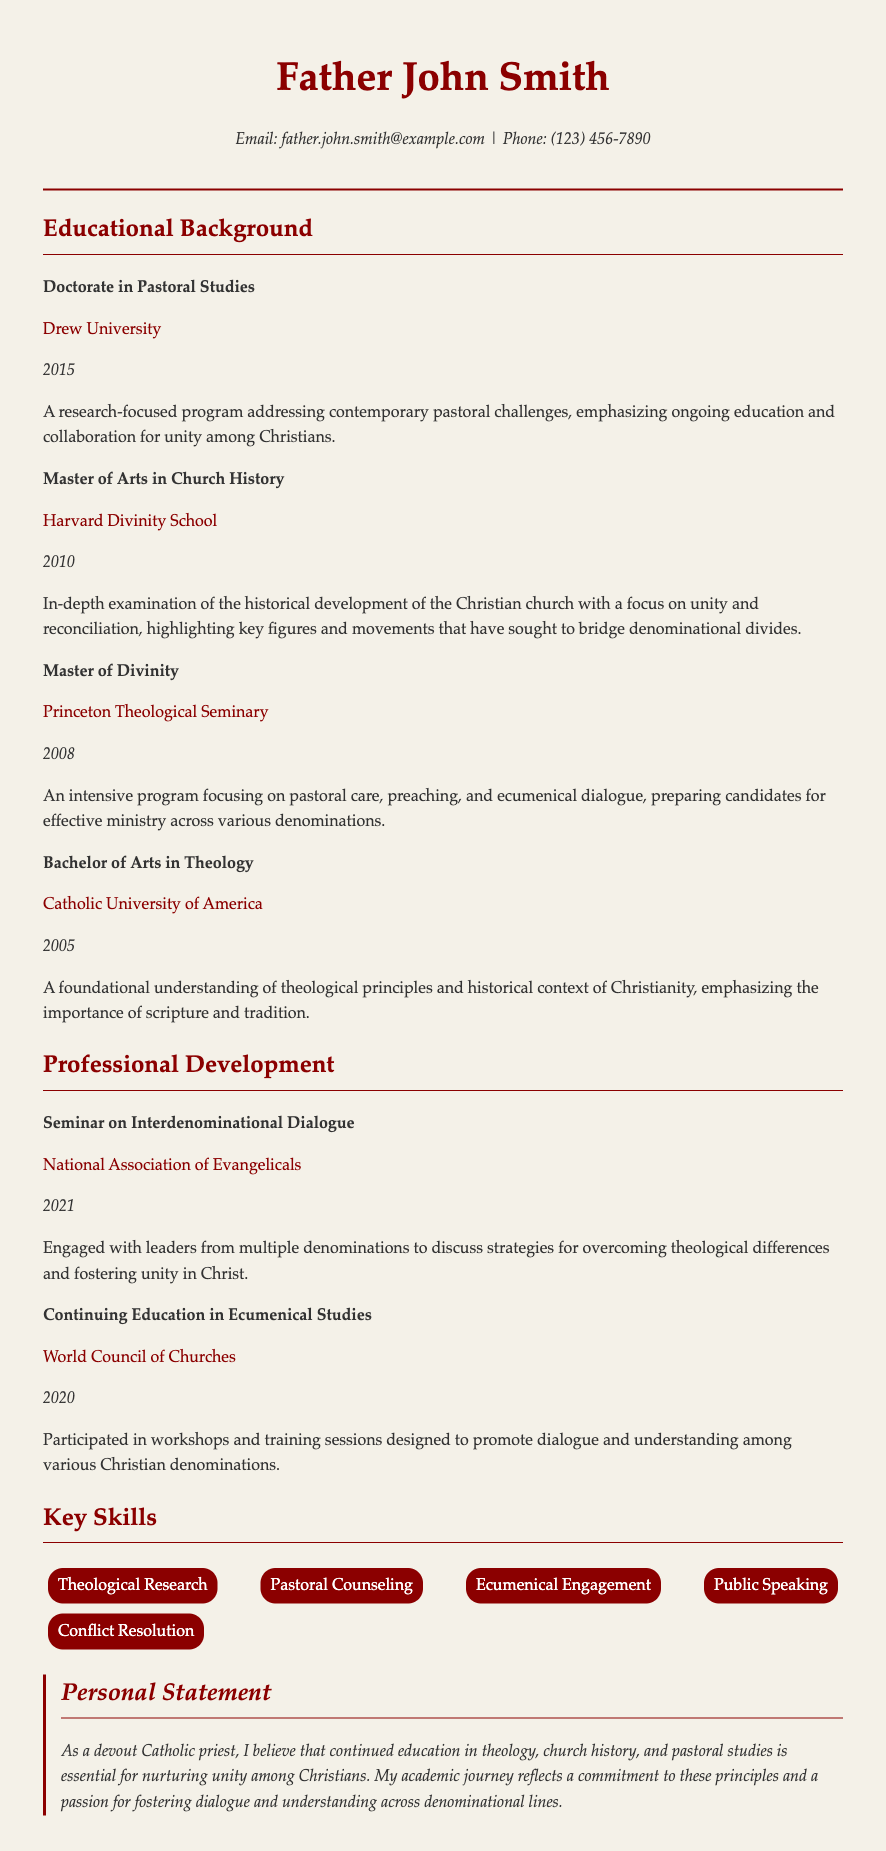what is the highest degree obtained? The highest degree listed in the document is the Doctorate in Pastoral Studies.
Answer: Doctorate in Pastoral Studies which institution awarded the Master of Arts in Church History? The institution that awarded the Master of Arts in Church History is mentioned in the education section.
Answer: Harvard Divinity School what year did Father John Smith complete his Bachelor of Arts in Theology? The document states that Father John Smith completed his Bachelor of Arts in Theology in 2005.
Answer: 2005 what is emphasized in the Doctorate in Pastoral Studies program? The description of the Doctorate program highlights the importance of ongoing education and collaboration for unity among Christians.
Answer: ongoing education and collaboration for unity among Christians how many professional development listings are included? The document includes two professional development items listed in the section.
Answer: 2 what type of studies did Father John Smith participate in with the World Council of Churches? The document specifies that Father John Smith participated in Continuing Education in Ecumenical Studies.
Answer: Continuing Education in Ecumenical Studies what is Father John Smith's personal statement about? The personal statement reflects his belief in the importance of continued education in theology and unity among Christians.
Answer: continued education in theology and unity among Christians what skill is related to engaging with multiple denominations? The key skills section includes a skill directly related to this, as mentioned in the document.
Answer: Ecumenical Engagement 